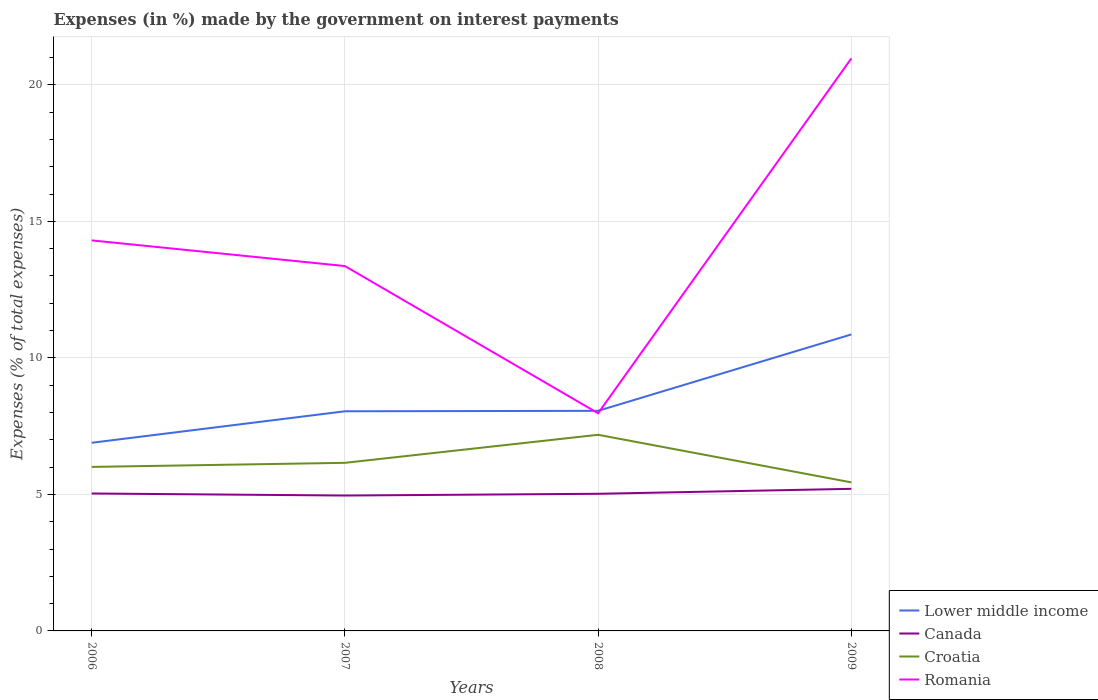How many different coloured lines are there?
Make the answer very short. 4. Across all years, what is the maximum percentage of expenses made by the government on interest payments in Romania?
Offer a very short reply. 7.97. What is the total percentage of expenses made by the government on interest payments in Romania in the graph?
Ensure brevity in your answer.  0.94. What is the difference between the highest and the second highest percentage of expenses made by the government on interest payments in Lower middle income?
Provide a succinct answer. 3.97. How many lines are there?
Keep it short and to the point. 4. What is the difference between two consecutive major ticks on the Y-axis?
Offer a terse response. 5. Does the graph contain any zero values?
Keep it short and to the point. No. How many legend labels are there?
Ensure brevity in your answer.  4. How are the legend labels stacked?
Keep it short and to the point. Vertical. What is the title of the graph?
Keep it short and to the point. Expenses (in %) made by the government on interest payments. What is the label or title of the X-axis?
Your answer should be compact. Years. What is the label or title of the Y-axis?
Your response must be concise. Expenses (% of total expenses). What is the Expenses (% of total expenses) in Lower middle income in 2006?
Ensure brevity in your answer.  6.89. What is the Expenses (% of total expenses) in Canada in 2006?
Make the answer very short. 5.03. What is the Expenses (% of total expenses) of Croatia in 2006?
Your response must be concise. 6.01. What is the Expenses (% of total expenses) in Romania in 2006?
Make the answer very short. 14.3. What is the Expenses (% of total expenses) in Lower middle income in 2007?
Ensure brevity in your answer.  8.04. What is the Expenses (% of total expenses) of Canada in 2007?
Provide a succinct answer. 4.96. What is the Expenses (% of total expenses) in Croatia in 2007?
Give a very brief answer. 6.16. What is the Expenses (% of total expenses) in Romania in 2007?
Your answer should be compact. 13.36. What is the Expenses (% of total expenses) of Lower middle income in 2008?
Provide a short and direct response. 8.06. What is the Expenses (% of total expenses) of Canada in 2008?
Offer a very short reply. 5.02. What is the Expenses (% of total expenses) of Croatia in 2008?
Provide a short and direct response. 7.18. What is the Expenses (% of total expenses) in Romania in 2008?
Keep it short and to the point. 7.97. What is the Expenses (% of total expenses) in Lower middle income in 2009?
Provide a short and direct response. 10.86. What is the Expenses (% of total expenses) in Canada in 2009?
Make the answer very short. 5.2. What is the Expenses (% of total expenses) in Croatia in 2009?
Offer a very short reply. 5.44. What is the Expenses (% of total expenses) of Romania in 2009?
Offer a terse response. 20.97. Across all years, what is the maximum Expenses (% of total expenses) in Lower middle income?
Keep it short and to the point. 10.86. Across all years, what is the maximum Expenses (% of total expenses) of Canada?
Make the answer very short. 5.2. Across all years, what is the maximum Expenses (% of total expenses) in Croatia?
Your answer should be very brief. 7.18. Across all years, what is the maximum Expenses (% of total expenses) in Romania?
Offer a terse response. 20.97. Across all years, what is the minimum Expenses (% of total expenses) of Lower middle income?
Ensure brevity in your answer.  6.89. Across all years, what is the minimum Expenses (% of total expenses) in Canada?
Your answer should be compact. 4.96. Across all years, what is the minimum Expenses (% of total expenses) of Croatia?
Your response must be concise. 5.44. Across all years, what is the minimum Expenses (% of total expenses) in Romania?
Offer a terse response. 7.97. What is the total Expenses (% of total expenses) in Lower middle income in the graph?
Ensure brevity in your answer.  33.85. What is the total Expenses (% of total expenses) of Canada in the graph?
Make the answer very short. 20.22. What is the total Expenses (% of total expenses) in Croatia in the graph?
Ensure brevity in your answer.  24.79. What is the total Expenses (% of total expenses) of Romania in the graph?
Ensure brevity in your answer.  56.61. What is the difference between the Expenses (% of total expenses) in Lower middle income in 2006 and that in 2007?
Make the answer very short. -1.15. What is the difference between the Expenses (% of total expenses) of Canada in 2006 and that in 2007?
Offer a terse response. 0.07. What is the difference between the Expenses (% of total expenses) of Croatia in 2006 and that in 2007?
Ensure brevity in your answer.  -0.15. What is the difference between the Expenses (% of total expenses) of Romania in 2006 and that in 2007?
Give a very brief answer. 0.94. What is the difference between the Expenses (% of total expenses) of Lower middle income in 2006 and that in 2008?
Provide a short and direct response. -1.17. What is the difference between the Expenses (% of total expenses) of Canada in 2006 and that in 2008?
Offer a very short reply. 0.01. What is the difference between the Expenses (% of total expenses) in Croatia in 2006 and that in 2008?
Offer a very short reply. -1.18. What is the difference between the Expenses (% of total expenses) in Romania in 2006 and that in 2008?
Your response must be concise. 6.33. What is the difference between the Expenses (% of total expenses) of Lower middle income in 2006 and that in 2009?
Provide a short and direct response. -3.97. What is the difference between the Expenses (% of total expenses) of Canada in 2006 and that in 2009?
Make the answer very short. -0.17. What is the difference between the Expenses (% of total expenses) of Croatia in 2006 and that in 2009?
Offer a very short reply. 0.57. What is the difference between the Expenses (% of total expenses) of Romania in 2006 and that in 2009?
Offer a terse response. -6.66. What is the difference between the Expenses (% of total expenses) in Lower middle income in 2007 and that in 2008?
Make the answer very short. -0.02. What is the difference between the Expenses (% of total expenses) in Canada in 2007 and that in 2008?
Offer a very short reply. -0.06. What is the difference between the Expenses (% of total expenses) of Croatia in 2007 and that in 2008?
Provide a succinct answer. -1.03. What is the difference between the Expenses (% of total expenses) of Romania in 2007 and that in 2008?
Keep it short and to the point. 5.39. What is the difference between the Expenses (% of total expenses) in Lower middle income in 2007 and that in 2009?
Give a very brief answer. -2.81. What is the difference between the Expenses (% of total expenses) in Canada in 2007 and that in 2009?
Offer a very short reply. -0.25. What is the difference between the Expenses (% of total expenses) of Croatia in 2007 and that in 2009?
Ensure brevity in your answer.  0.72. What is the difference between the Expenses (% of total expenses) in Romania in 2007 and that in 2009?
Offer a very short reply. -7.6. What is the difference between the Expenses (% of total expenses) of Lower middle income in 2008 and that in 2009?
Your answer should be very brief. -2.8. What is the difference between the Expenses (% of total expenses) of Canada in 2008 and that in 2009?
Provide a short and direct response. -0.18. What is the difference between the Expenses (% of total expenses) in Croatia in 2008 and that in 2009?
Offer a terse response. 1.74. What is the difference between the Expenses (% of total expenses) in Romania in 2008 and that in 2009?
Ensure brevity in your answer.  -13. What is the difference between the Expenses (% of total expenses) of Lower middle income in 2006 and the Expenses (% of total expenses) of Canada in 2007?
Provide a short and direct response. 1.93. What is the difference between the Expenses (% of total expenses) of Lower middle income in 2006 and the Expenses (% of total expenses) of Croatia in 2007?
Keep it short and to the point. 0.73. What is the difference between the Expenses (% of total expenses) of Lower middle income in 2006 and the Expenses (% of total expenses) of Romania in 2007?
Give a very brief answer. -6.47. What is the difference between the Expenses (% of total expenses) of Canada in 2006 and the Expenses (% of total expenses) of Croatia in 2007?
Your answer should be very brief. -1.12. What is the difference between the Expenses (% of total expenses) in Canada in 2006 and the Expenses (% of total expenses) in Romania in 2007?
Your response must be concise. -8.33. What is the difference between the Expenses (% of total expenses) of Croatia in 2006 and the Expenses (% of total expenses) of Romania in 2007?
Make the answer very short. -7.36. What is the difference between the Expenses (% of total expenses) in Lower middle income in 2006 and the Expenses (% of total expenses) in Canada in 2008?
Make the answer very short. 1.87. What is the difference between the Expenses (% of total expenses) of Lower middle income in 2006 and the Expenses (% of total expenses) of Croatia in 2008?
Offer a very short reply. -0.29. What is the difference between the Expenses (% of total expenses) of Lower middle income in 2006 and the Expenses (% of total expenses) of Romania in 2008?
Your answer should be compact. -1.08. What is the difference between the Expenses (% of total expenses) of Canada in 2006 and the Expenses (% of total expenses) of Croatia in 2008?
Offer a terse response. -2.15. What is the difference between the Expenses (% of total expenses) of Canada in 2006 and the Expenses (% of total expenses) of Romania in 2008?
Keep it short and to the point. -2.94. What is the difference between the Expenses (% of total expenses) of Croatia in 2006 and the Expenses (% of total expenses) of Romania in 2008?
Provide a short and direct response. -1.96. What is the difference between the Expenses (% of total expenses) of Lower middle income in 2006 and the Expenses (% of total expenses) of Canada in 2009?
Your answer should be very brief. 1.69. What is the difference between the Expenses (% of total expenses) in Lower middle income in 2006 and the Expenses (% of total expenses) in Croatia in 2009?
Your answer should be compact. 1.45. What is the difference between the Expenses (% of total expenses) in Lower middle income in 2006 and the Expenses (% of total expenses) in Romania in 2009?
Make the answer very short. -14.08. What is the difference between the Expenses (% of total expenses) in Canada in 2006 and the Expenses (% of total expenses) in Croatia in 2009?
Give a very brief answer. -0.41. What is the difference between the Expenses (% of total expenses) of Canada in 2006 and the Expenses (% of total expenses) of Romania in 2009?
Ensure brevity in your answer.  -15.93. What is the difference between the Expenses (% of total expenses) in Croatia in 2006 and the Expenses (% of total expenses) in Romania in 2009?
Offer a terse response. -14.96. What is the difference between the Expenses (% of total expenses) in Lower middle income in 2007 and the Expenses (% of total expenses) in Canada in 2008?
Your answer should be very brief. 3.02. What is the difference between the Expenses (% of total expenses) of Lower middle income in 2007 and the Expenses (% of total expenses) of Croatia in 2008?
Offer a terse response. 0.86. What is the difference between the Expenses (% of total expenses) of Lower middle income in 2007 and the Expenses (% of total expenses) of Romania in 2008?
Give a very brief answer. 0.07. What is the difference between the Expenses (% of total expenses) in Canada in 2007 and the Expenses (% of total expenses) in Croatia in 2008?
Give a very brief answer. -2.22. What is the difference between the Expenses (% of total expenses) in Canada in 2007 and the Expenses (% of total expenses) in Romania in 2008?
Offer a very short reply. -3.01. What is the difference between the Expenses (% of total expenses) in Croatia in 2007 and the Expenses (% of total expenses) in Romania in 2008?
Ensure brevity in your answer.  -1.82. What is the difference between the Expenses (% of total expenses) in Lower middle income in 2007 and the Expenses (% of total expenses) in Canada in 2009?
Give a very brief answer. 2.84. What is the difference between the Expenses (% of total expenses) in Lower middle income in 2007 and the Expenses (% of total expenses) in Croatia in 2009?
Give a very brief answer. 2.6. What is the difference between the Expenses (% of total expenses) of Lower middle income in 2007 and the Expenses (% of total expenses) of Romania in 2009?
Offer a very short reply. -12.92. What is the difference between the Expenses (% of total expenses) in Canada in 2007 and the Expenses (% of total expenses) in Croatia in 2009?
Your answer should be very brief. -0.48. What is the difference between the Expenses (% of total expenses) in Canada in 2007 and the Expenses (% of total expenses) in Romania in 2009?
Offer a terse response. -16.01. What is the difference between the Expenses (% of total expenses) in Croatia in 2007 and the Expenses (% of total expenses) in Romania in 2009?
Offer a very short reply. -14.81. What is the difference between the Expenses (% of total expenses) in Lower middle income in 2008 and the Expenses (% of total expenses) in Canada in 2009?
Provide a short and direct response. 2.86. What is the difference between the Expenses (% of total expenses) of Lower middle income in 2008 and the Expenses (% of total expenses) of Croatia in 2009?
Give a very brief answer. 2.62. What is the difference between the Expenses (% of total expenses) of Lower middle income in 2008 and the Expenses (% of total expenses) of Romania in 2009?
Make the answer very short. -12.91. What is the difference between the Expenses (% of total expenses) of Canada in 2008 and the Expenses (% of total expenses) of Croatia in 2009?
Offer a terse response. -0.42. What is the difference between the Expenses (% of total expenses) of Canada in 2008 and the Expenses (% of total expenses) of Romania in 2009?
Provide a succinct answer. -15.94. What is the difference between the Expenses (% of total expenses) in Croatia in 2008 and the Expenses (% of total expenses) in Romania in 2009?
Ensure brevity in your answer.  -13.78. What is the average Expenses (% of total expenses) in Lower middle income per year?
Provide a short and direct response. 8.46. What is the average Expenses (% of total expenses) in Canada per year?
Provide a short and direct response. 5.05. What is the average Expenses (% of total expenses) of Croatia per year?
Provide a succinct answer. 6.2. What is the average Expenses (% of total expenses) of Romania per year?
Your answer should be compact. 14.15. In the year 2006, what is the difference between the Expenses (% of total expenses) in Lower middle income and Expenses (% of total expenses) in Canada?
Your answer should be very brief. 1.86. In the year 2006, what is the difference between the Expenses (% of total expenses) of Lower middle income and Expenses (% of total expenses) of Croatia?
Ensure brevity in your answer.  0.88. In the year 2006, what is the difference between the Expenses (% of total expenses) in Lower middle income and Expenses (% of total expenses) in Romania?
Keep it short and to the point. -7.41. In the year 2006, what is the difference between the Expenses (% of total expenses) in Canada and Expenses (% of total expenses) in Croatia?
Offer a terse response. -0.97. In the year 2006, what is the difference between the Expenses (% of total expenses) in Canada and Expenses (% of total expenses) in Romania?
Keep it short and to the point. -9.27. In the year 2006, what is the difference between the Expenses (% of total expenses) in Croatia and Expenses (% of total expenses) in Romania?
Provide a short and direct response. -8.3. In the year 2007, what is the difference between the Expenses (% of total expenses) of Lower middle income and Expenses (% of total expenses) of Canada?
Provide a short and direct response. 3.09. In the year 2007, what is the difference between the Expenses (% of total expenses) in Lower middle income and Expenses (% of total expenses) in Croatia?
Offer a very short reply. 1.89. In the year 2007, what is the difference between the Expenses (% of total expenses) in Lower middle income and Expenses (% of total expenses) in Romania?
Your answer should be compact. -5.32. In the year 2007, what is the difference between the Expenses (% of total expenses) of Canada and Expenses (% of total expenses) of Croatia?
Give a very brief answer. -1.2. In the year 2007, what is the difference between the Expenses (% of total expenses) in Canada and Expenses (% of total expenses) in Romania?
Your answer should be compact. -8.4. In the year 2007, what is the difference between the Expenses (% of total expenses) of Croatia and Expenses (% of total expenses) of Romania?
Your response must be concise. -7.21. In the year 2008, what is the difference between the Expenses (% of total expenses) in Lower middle income and Expenses (% of total expenses) in Canada?
Offer a very short reply. 3.04. In the year 2008, what is the difference between the Expenses (% of total expenses) in Lower middle income and Expenses (% of total expenses) in Croatia?
Keep it short and to the point. 0.88. In the year 2008, what is the difference between the Expenses (% of total expenses) in Lower middle income and Expenses (% of total expenses) in Romania?
Keep it short and to the point. 0.09. In the year 2008, what is the difference between the Expenses (% of total expenses) of Canada and Expenses (% of total expenses) of Croatia?
Provide a succinct answer. -2.16. In the year 2008, what is the difference between the Expenses (% of total expenses) in Canada and Expenses (% of total expenses) in Romania?
Offer a very short reply. -2.95. In the year 2008, what is the difference between the Expenses (% of total expenses) of Croatia and Expenses (% of total expenses) of Romania?
Your response must be concise. -0.79. In the year 2009, what is the difference between the Expenses (% of total expenses) in Lower middle income and Expenses (% of total expenses) in Canada?
Ensure brevity in your answer.  5.65. In the year 2009, what is the difference between the Expenses (% of total expenses) in Lower middle income and Expenses (% of total expenses) in Croatia?
Offer a very short reply. 5.42. In the year 2009, what is the difference between the Expenses (% of total expenses) of Lower middle income and Expenses (% of total expenses) of Romania?
Give a very brief answer. -10.11. In the year 2009, what is the difference between the Expenses (% of total expenses) of Canada and Expenses (% of total expenses) of Croatia?
Make the answer very short. -0.24. In the year 2009, what is the difference between the Expenses (% of total expenses) of Canada and Expenses (% of total expenses) of Romania?
Ensure brevity in your answer.  -15.76. In the year 2009, what is the difference between the Expenses (% of total expenses) in Croatia and Expenses (% of total expenses) in Romania?
Offer a terse response. -15.53. What is the ratio of the Expenses (% of total expenses) in Lower middle income in 2006 to that in 2007?
Offer a very short reply. 0.86. What is the ratio of the Expenses (% of total expenses) of Canada in 2006 to that in 2007?
Your response must be concise. 1.02. What is the ratio of the Expenses (% of total expenses) of Croatia in 2006 to that in 2007?
Your answer should be very brief. 0.98. What is the ratio of the Expenses (% of total expenses) in Romania in 2006 to that in 2007?
Your answer should be very brief. 1.07. What is the ratio of the Expenses (% of total expenses) in Lower middle income in 2006 to that in 2008?
Your response must be concise. 0.85. What is the ratio of the Expenses (% of total expenses) in Croatia in 2006 to that in 2008?
Provide a short and direct response. 0.84. What is the ratio of the Expenses (% of total expenses) of Romania in 2006 to that in 2008?
Offer a very short reply. 1.79. What is the ratio of the Expenses (% of total expenses) of Lower middle income in 2006 to that in 2009?
Ensure brevity in your answer.  0.63. What is the ratio of the Expenses (% of total expenses) of Canada in 2006 to that in 2009?
Keep it short and to the point. 0.97. What is the ratio of the Expenses (% of total expenses) of Croatia in 2006 to that in 2009?
Offer a terse response. 1.1. What is the ratio of the Expenses (% of total expenses) of Romania in 2006 to that in 2009?
Your response must be concise. 0.68. What is the ratio of the Expenses (% of total expenses) in Canada in 2007 to that in 2008?
Offer a very short reply. 0.99. What is the ratio of the Expenses (% of total expenses) in Croatia in 2007 to that in 2008?
Keep it short and to the point. 0.86. What is the ratio of the Expenses (% of total expenses) in Romania in 2007 to that in 2008?
Your answer should be very brief. 1.68. What is the ratio of the Expenses (% of total expenses) in Lower middle income in 2007 to that in 2009?
Provide a short and direct response. 0.74. What is the ratio of the Expenses (% of total expenses) of Canada in 2007 to that in 2009?
Your answer should be very brief. 0.95. What is the ratio of the Expenses (% of total expenses) in Croatia in 2007 to that in 2009?
Your answer should be compact. 1.13. What is the ratio of the Expenses (% of total expenses) of Romania in 2007 to that in 2009?
Keep it short and to the point. 0.64. What is the ratio of the Expenses (% of total expenses) of Lower middle income in 2008 to that in 2009?
Ensure brevity in your answer.  0.74. What is the ratio of the Expenses (% of total expenses) in Canada in 2008 to that in 2009?
Your answer should be very brief. 0.97. What is the ratio of the Expenses (% of total expenses) in Croatia in 2008 to that in 2009?
Offer a terse response. 1.32. What is the ratio of the Expenses (% of total expenses) of Romania in 2008 to that in 2009?
Your answer should be compact. 0.38. What is the difference between the highest and the second highest Expenses (% of total expenses) of Lower middle income?
Make the answer very short. 2.8. What is the difference between the highest and the second highest Expenses (% of total expenses) in Canada?
Give a very brief answer. 0.17. What is the difference between the highest and the second highest Expenses (% of total expenses) in Croatia?
Keep it short and to the point. 1.03. What is the difference between the highest and the second highest Expenses (% of total expenses) of Romania?
Your answer should be compact. 6.66. What is the difference between the highest and the lowest Expenses (% of total expenses) in Lower middle income?
Provide a succinct answer. 3.97. What is the difference between the highest and the lowest Expenses (% of total expenses) in Canada?
Ensure brevity in your answer.  0.25. What is the difference between the highest and the lowest Expenses (% of total expenses) of Croatia?
Provide a short and direct response. 1.74. What is the difference between the highest and the lowest Expenses (% of total expenses) in Romania?
Keep it short and to the point. 13. 